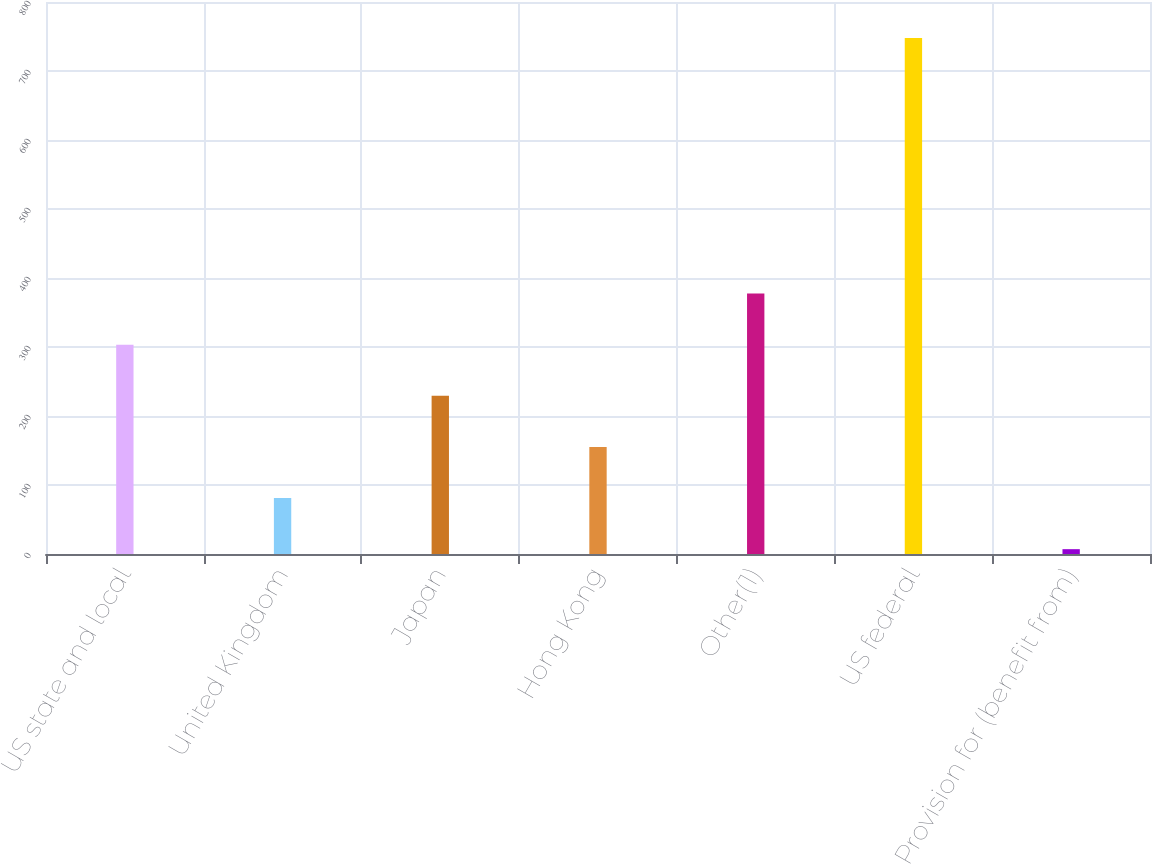Convert chart. <chart><loc_0><loc_0><loc_500><loc_500><bar_chart><fcel>US state and local<fcel>United Kingdom<fcel>Japan<fcel>Hong Kong<fcel>Other(1)<fcel>US federal<fcel>Provision for (benefit from)<nl><fcel>303.4<fcel>81.1<fcel>229.3<fcel>155.2<fcel>377.5<fcel>748<fcel>7<nl></chart> 